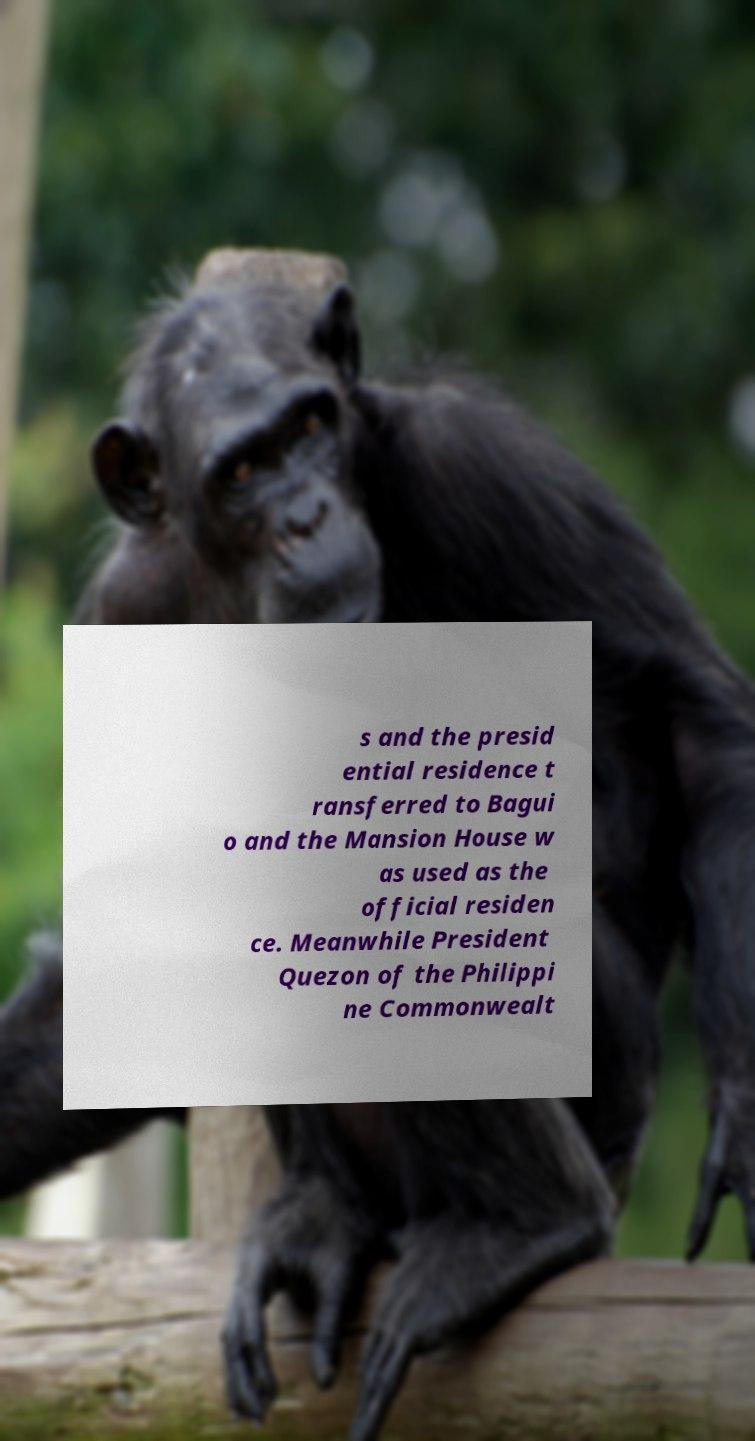Could you assist in decoding the text presented in this image and type it out clearly? s and the presid ential residence t ransferred to Bagui o and the Mansion House w as used as the official residen ce. Meanwhile President Quezon of the Philippi ne Commonwealt 